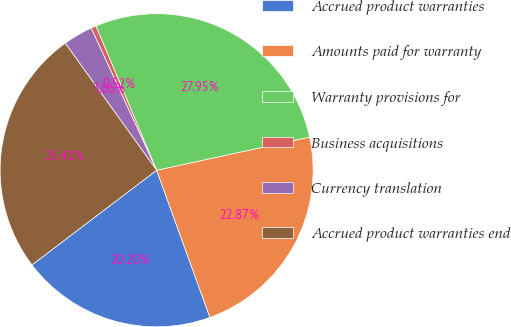Convert chart. <chart><loc_0><loc_0><loc_500><loc_500><pie_chart><fcel>Accrued product warranties<fcel>Amounts paid for warranty<fcel>Warranty provisions for<fcel>Business acquisitions<fcel>Currency translation<fcel>Accrued product warranties end<nl><fcel>20.2%<fcel>22.87%<fcel>27.95%<fcel>0.52%<fcel>3.06%<fcel>25.41%<nl></chart> 